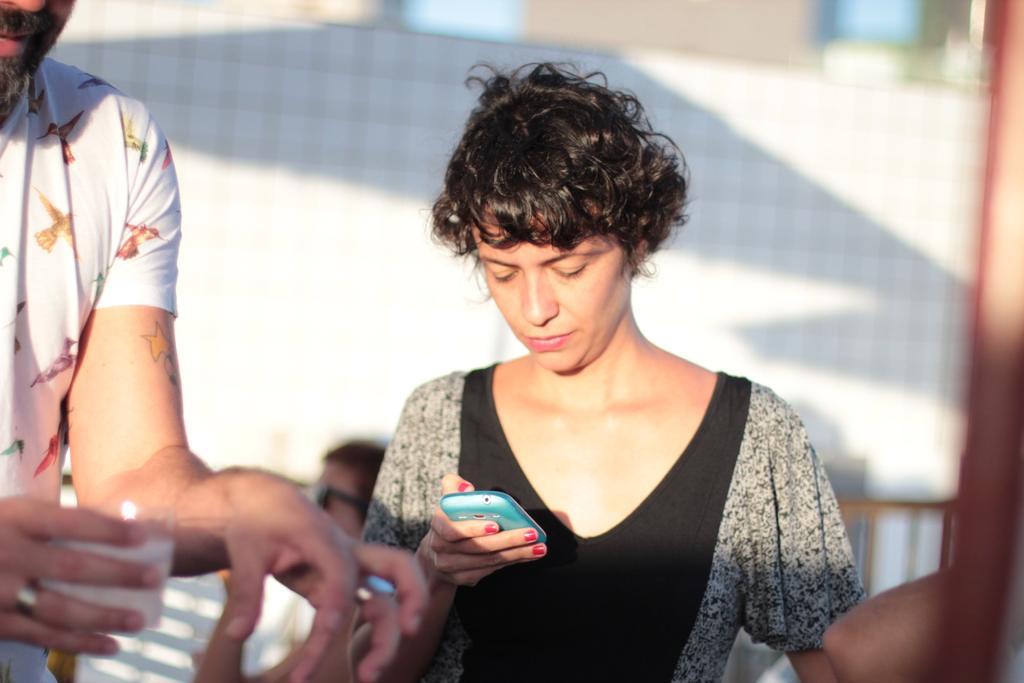How would you summarize this image in a sentence or two? This picture seems to be of outside. In the center there is a woman wearing black color t-shirt, holding a mobile phone and looking into it. On the left there is a man wearing white color t-shirt and holding a glass. In the background we can see a wall. 